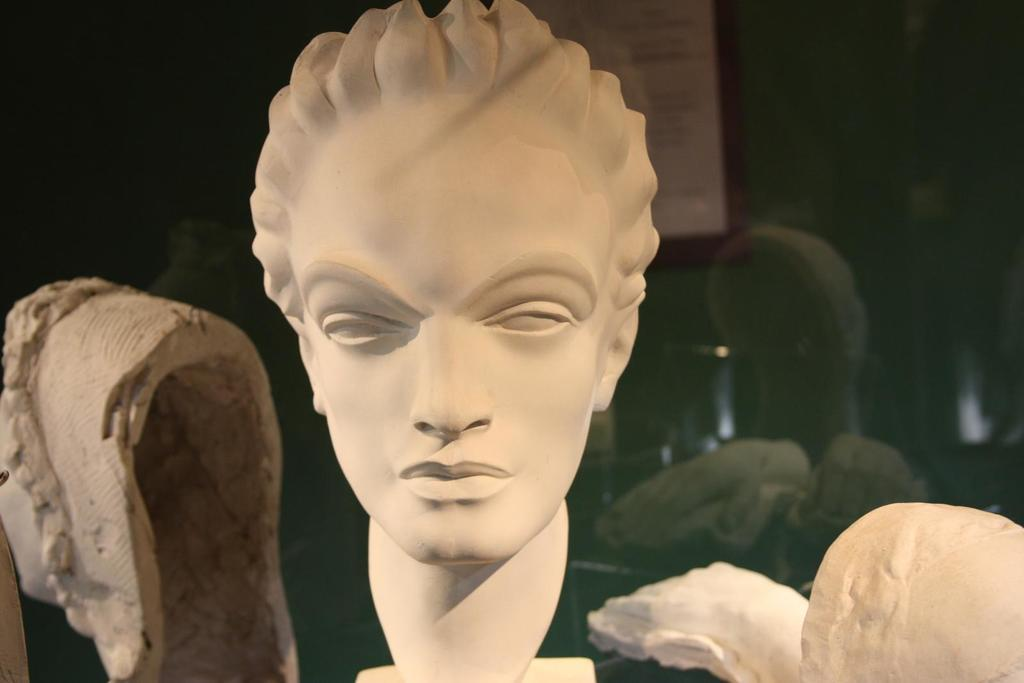What is the main subject of the image? There is a depiction of a person's face in the image. What type of bed is visible in the image? There is no bed present in the image; it only features a depiction of a person's face. What type of locket is the person wearing in the image? There is no locket visible in the image; only the person's face is depicted. 